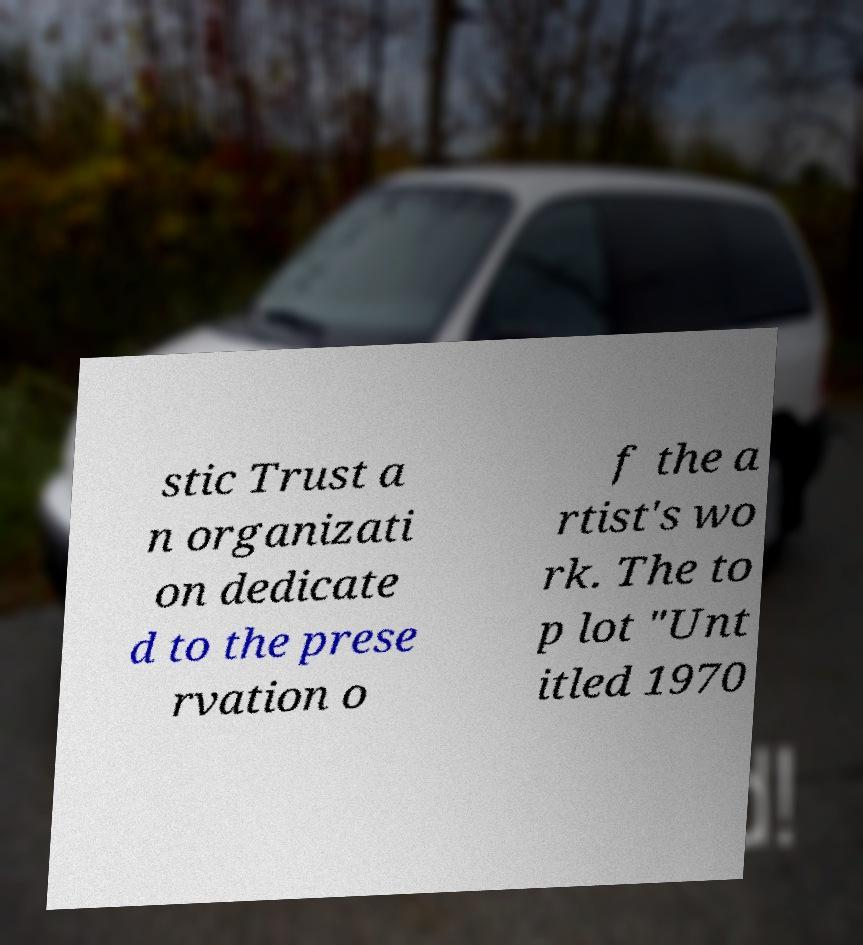What messages or text are displayed in this image? I need them in a readable, typed format. stic Trust a n organizati on dedicate d to the prese rvation o f the a rtist's wo rk. The to p lot "Unt itled 1970 